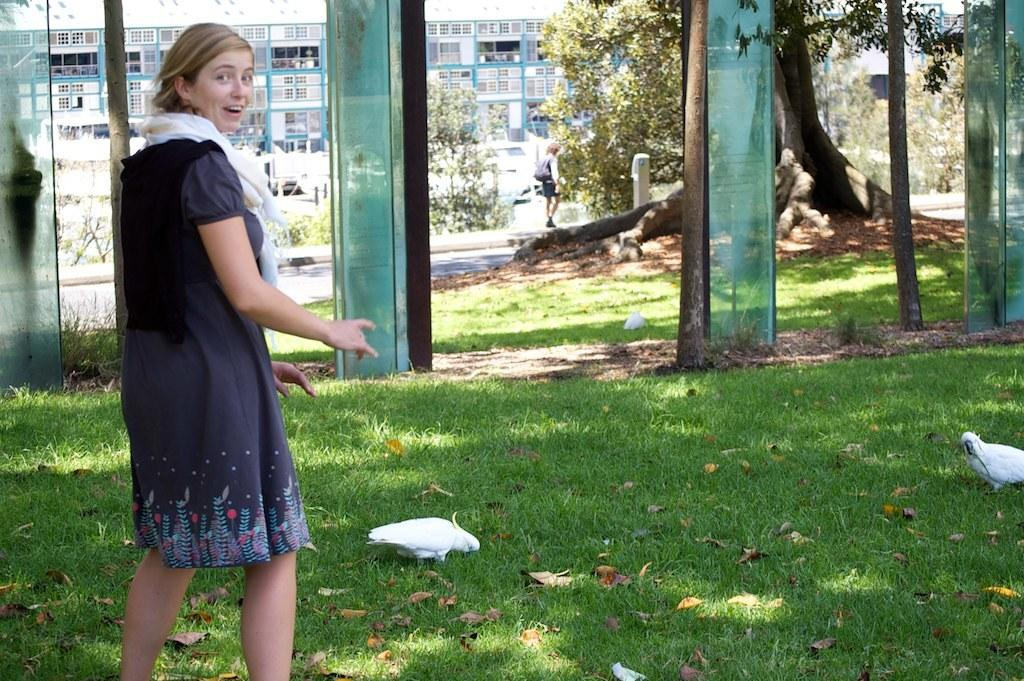What are the two people in the image doing? The two people in the image are walking. What objects can be seen behind the women? There are glasses behind the women. What type of natural environment is visible in the image? There are trees visible in the image. What type of structure is in the background? There is a building in the background. What animals can be seen on the grass in the image? There are two white birds on the grass. What type of gate can be seen in the image? There is no gate present in the image. What type of clouds can be seen in the image? The provided facts do not mention any clouds in the image. 